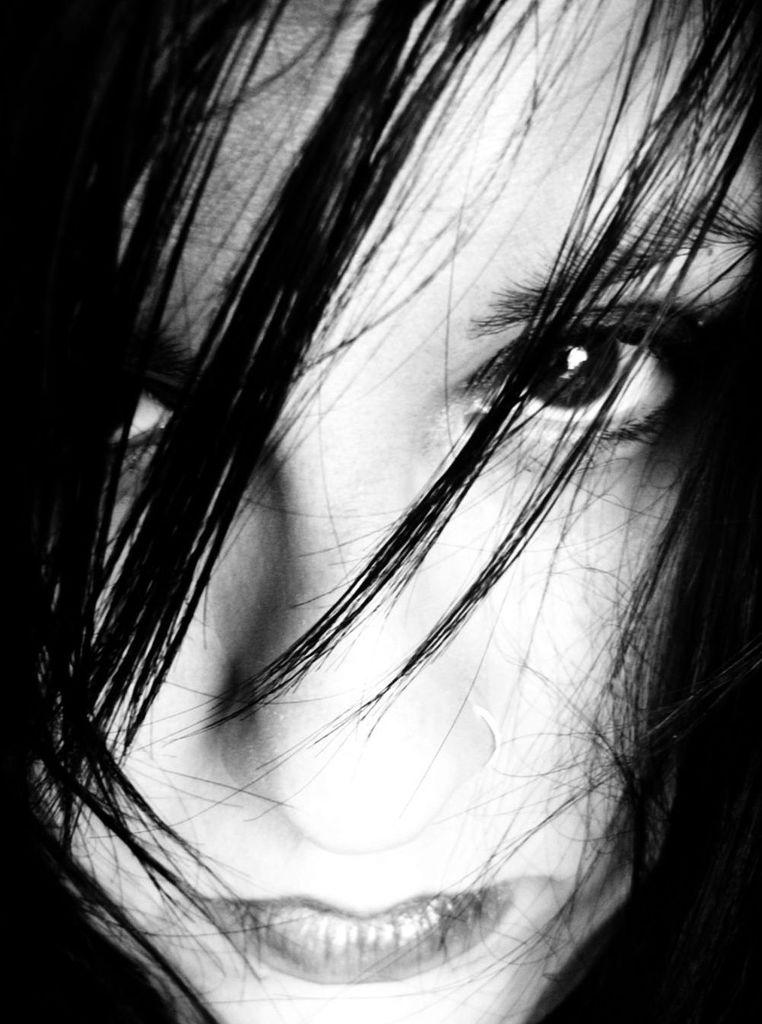Who is the main subject in the image? There is a woman in the center of the image. What type of wrench is the woman using in the image? There is no wrench present in the image; the main subject is a woman. Where is the station located in the image? There is no station present in the image; the main subject is a woman. 